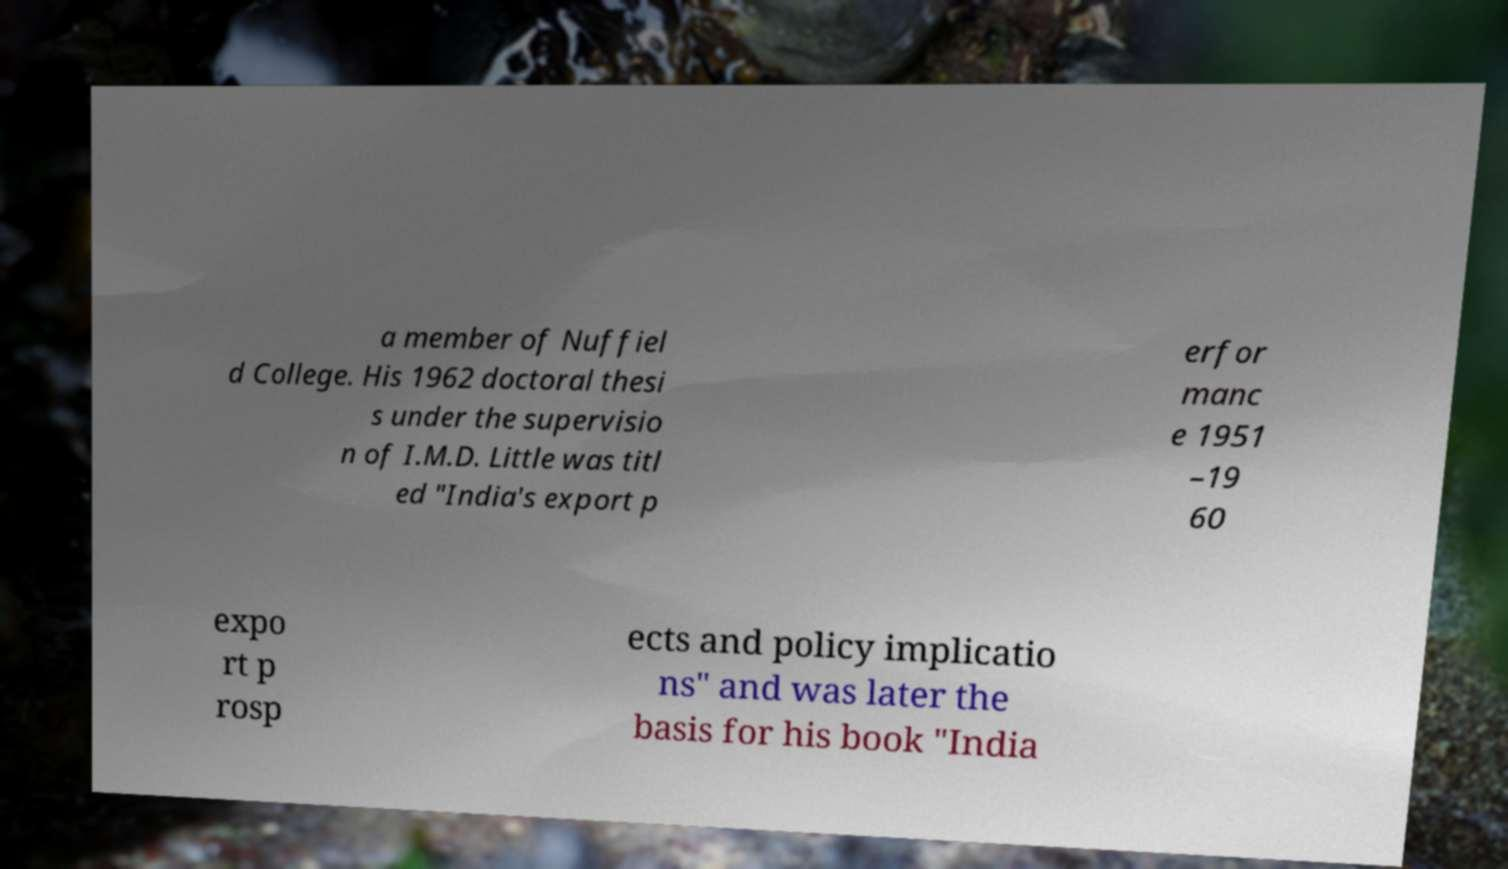Can you read and provide the text displayed in the image?This photo seems to have some interesting text. Can you extract and type it out for me? a member of Nuffiel d College. His 1962 doctoral thesi s under the supervisio n of I.M.D. Little was titl ed "India's export p erfor manc e 1951 –19 60 expo rt p rosp ects and policy implicatio ns" and was later the basis for his book "India 